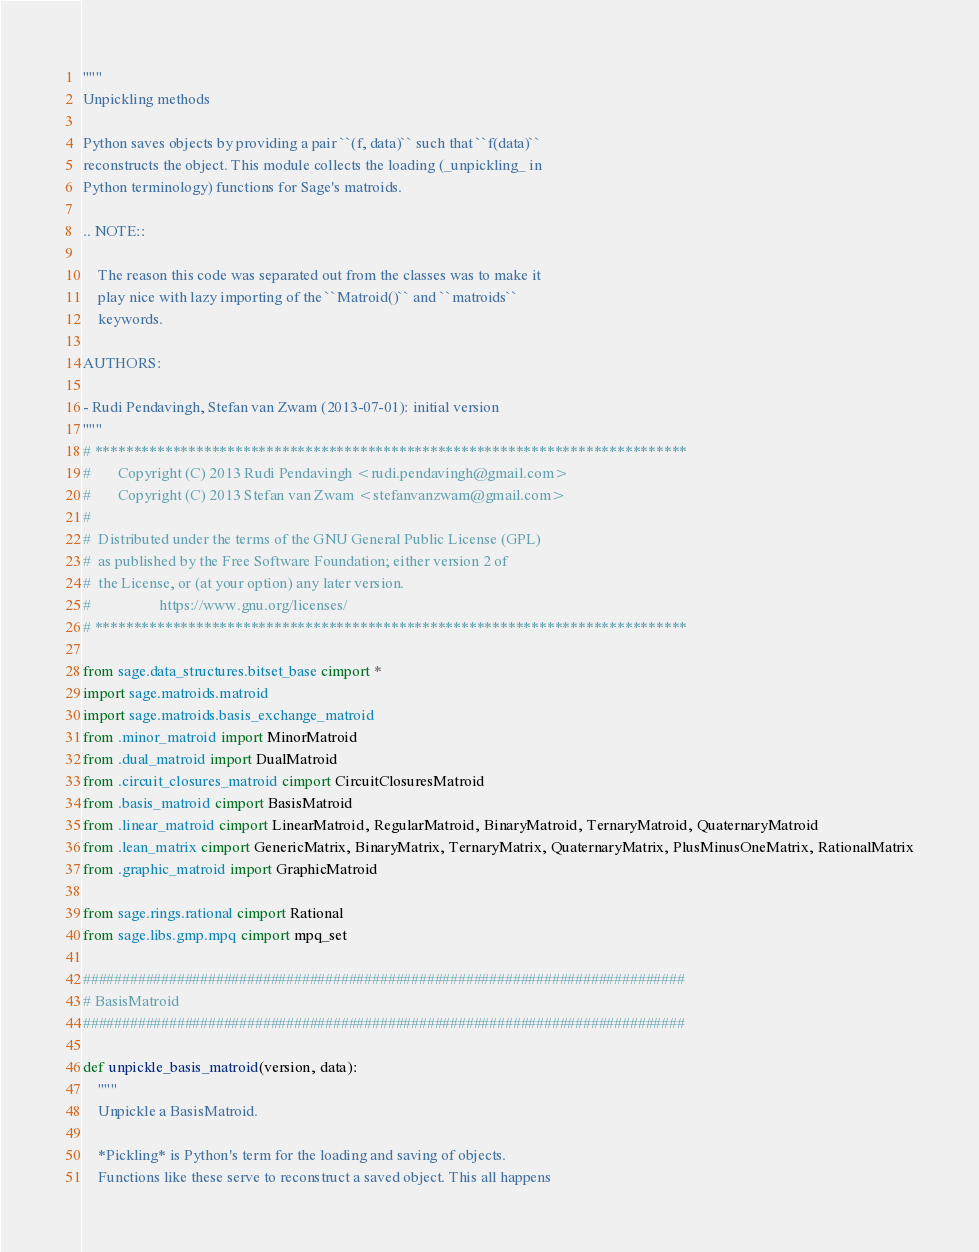<code> <loc_0><loc_0><loc_500><loc_500><_Cython_>"""
Unpickling methods

Python saves objects by providing a pair ``(f, data)`` such that ``f(data)``
reconstructs the object. This module collects the loading (_unpickling_ in
Python terminology) functions for Sage's matroids.

.. NOTE::

    The reason this code was separated out from the classes was to make it
    play nice with lazy importing of the ``Matroid()`` and ``matroids``
    keywords.

AUTHORS:

- Rudi Pendavingh, Stefan van Zwam (2013-07-01): initial version
"""
# ****************************************************************************
#       Copyright (C) 2013 Rudi Pendavingh <rudi.pendavingh@gmail.com>
#       Copyright (C) 2013 Stefan van Zwam <stefanvanzwam@gmail.com>
#
#  Distributed under the terms of the GNU General Public License (GPL)
#  as published by the Free Software Foundation; either version 2 of
#  the License, or (at your option) any later version.
#                  https://www.gnu.org/licenses/
# ****************************************************************************

from sage.data_structures.bitset_base cimport *
import sage.matroids.matroid
import sage.matroids.basis_exchange_matroid
from .minor_matroid import MinorMatroid
from .dual_matroid import DualMatroid
from .circuit_closures_matroid cimport CircuitClosuresMatroid
from .basis_matroid cimport BasisMatroid
from .linear_matroid cimport LinearMatroid, RegularMatroid, BinaryMatroid, TernaryMatroid, QuaternaryMatroid
from .lean_matrix cimport GenericMatrix, BinaryMatrix, TernaryMatrix, QuaternaryMatrix, PlusMinusOneMatrix, RationalMatrix
from .graphic_matroid import GraphicMatroid

from sage.rings.rational cimport Rational
from sage.libs.gmp.mpq cimport mpq_set

#############################################################################
# BasisMatroid
#############################################################################

def unpickle_basis_matroid(version, data):
    """
    Unpickle a BasisMatroid.

    *Pickling* is Python's term for the loading and saving of objects.
    Functions like these serve to reconstruct a saved object. This all happens</code> 